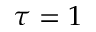<formula> <loc_0><loc_0><loc_500><loc_500>\tau = 1</formula> 